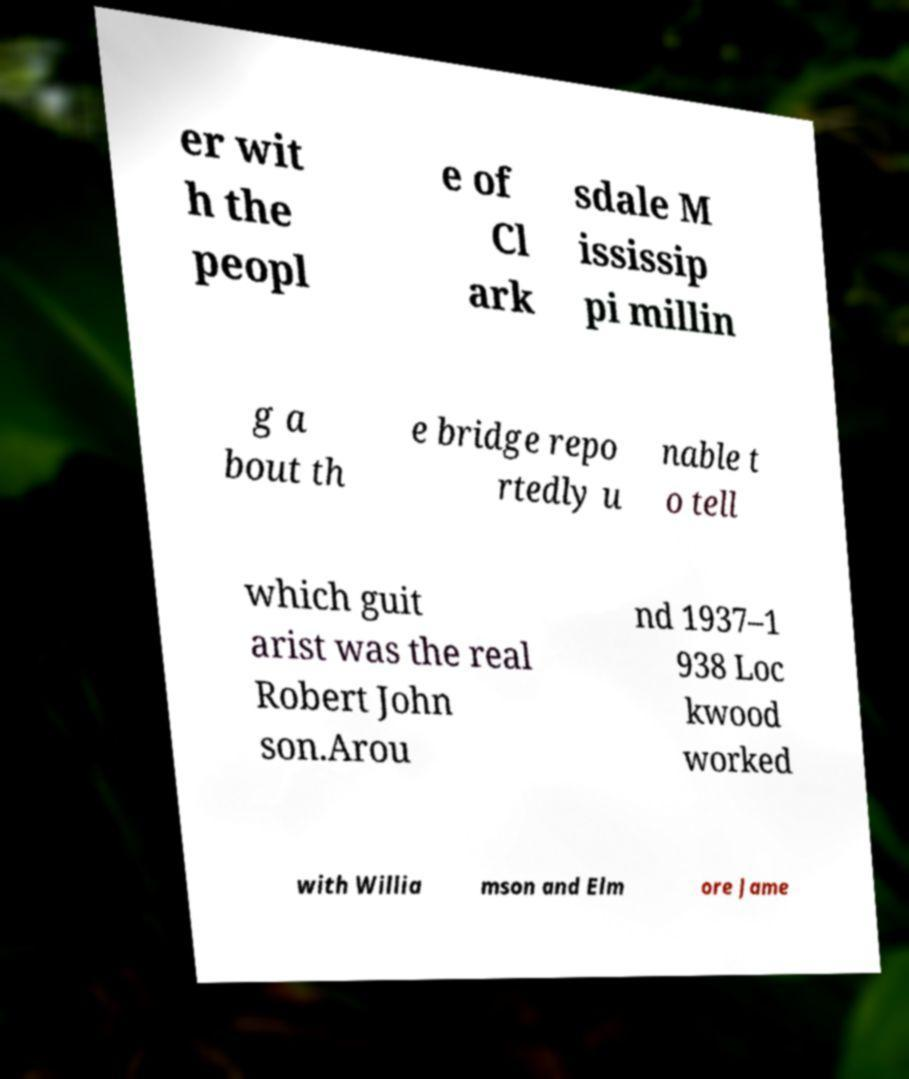There's text embedded in this image that I need extracted. Can you transcribe it verbatim? er wit h the peopl e of Cl ark sdale M ississip pi millin g a bout th e bridge repo rtedly u nable t o tell which guit arist was the real Robert John son.Arou nd 1937–1 938 Loc kwood worked with Willia mson and Elm ore Jame 